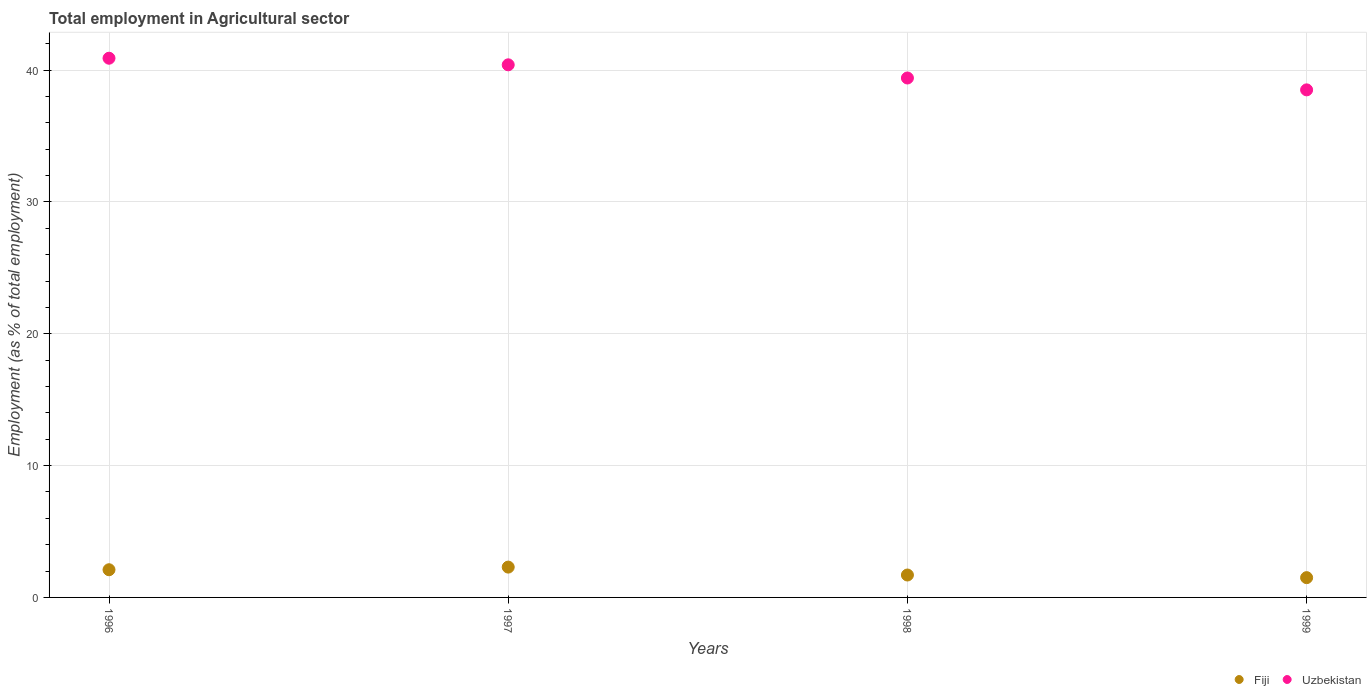What is the employment in agricultural sector in Fiji in 1996?
Give a very brief answer. 2.1. Across all years, what is the maximum employment in agricultural sector in Fiji?
Provide a succinct answer. 2.3. Across all years, what is the minimum employment in agricultural sector in Fiji?
Keep it short and to the point. 1.5. In which year was the employment in agricultural sector in Uzbekistan minimum?
Provide a succinct answer. 1999. What is the total employment in agricultural sector in Uzbekistan in the graph?
Ensure brevity in your answer.  159.2. What is the difference between the employment in agricultural sector in Fiji in 1997 and that in 1999?
Your response must be concise. 0.8. What is the difference between the employment in agricultural sector in Fiji in 1997 and the employment in agricultural sector in Uzbekistan in 1999?
Provide a short and direct response. -36.2. What is the average employment in agricultural sector in Uzbekistan per year?
Your answer should be very brief. 39.8. In the year 1999, what is the difference between the employment in agricultural sector in Fiji and employment in agricultural sector in Uzbekistan?
Give a very brief answer. -37. In how many years, is the employment in agricultural sector in Uzbekistan greater than 16 %?
Keep it short and to the point. 4. What is the ratio of the employment in agricultural sector in Fiji in 1998 to that in 1999?
Your response must be concise. 1.13. Is the employment in agricultural sector in Uzbekistan in 1998 less than that in 1999?
Your answer should be very brief. No. What is the difference between the highest and the second highest employment in agricultural sector in Uzbekistan?
Make the answer very short. 0.5. What is the difference between the highest and the lowest employment in agricultural sector in Uzbekistan?
Make the answer very short. 2.4. In how many years, is the employment in agricultural sector in Uzbekistan greater than the average employment in agricultural sector in Uzbekistan taken over all years?
Your answer should be very brief. 2. Is the employment in agricultural sector in Uzbekistan strictly less than the employment in agricultural sector in Fiji over the years?
Provide a short and direct response. No. How many dotlines are there?
Your answer should be very brief. 2. How many years are there in the graph?
Your answer should be very brief. 4. Are the values on the major ticks of Y-axis written in scientific E-notation?
Your response must be concise. No. Where does the legend appear in the graph?
Provide a succinct answer. Bottom right. How are the legend labels stacked?
Your answer should be very brief. Horizontal. What is the title of the graph?
Provide a short and direct response. Total employment in Agricultural sector. What is the label or title of the X-axis?
Your answer should be very brief. Years. What is the label or title of the Y-axis?
Keep it short and to the point. Employment (as % of total employment). What is the Employment (as % of total employment) in Fiji in 1996?
Offer a terse response. 2.1. What is the Employment (as % of total employment) in Uzbekistan in 1996?
Your answer should be compact. 40.9. What is the Employment (as % of total employment) of Fiji in 1997?
Give a very brief answer. 2.3. What is the Employment (as % of total employment) of Uzbekistan in 1997?
Ensure brevity in your answer.  40.4. What is the Employment (as % of total employment) of Fiji in 1998?
Keep it short and to the point. 1.7. What is the Employment (as % of total employment) of Uzbekistan in 1998?
Offer a terse response. 39.4. What is the Employment (as % of total employment) of Uzbekistan in 1999?
Provide a succinct answer. 38.5. Across all years, what is the maximum Employment (as % of total employment) of Fiji?
Your response must be concise. 2.3. Across all years, what is the maximum Employment (as % of total employment) in Uzbekistan?
Ensure brevity in your answer.  40.9. Across all years, what is the minimum Employment (as % of total employment) of Fiji?
Keep it short and to the point. 1.5. Across all years, what is the minimum Employment (as % of total employment) in Uzbekistan?
Provide a short and direct response. 38.5. What is the total Employment (as % of total employment) of Fiji in the graph?
Offer a terse response. 7.6. What is the total Employment (as % of total employment) of Uzbekistan in the graph?
Provide a succinct answer. 159.2. What is the difference between the Employment (as % of total employment) of Uzbekistan in 1996 and that in 1998?
Provide a succinct answer. 1.5. What is the difference between the Employment (as % of total employment) in Fiji in 1996 and that in 1999?
Your response must be concise. 0.6. What is the difference between the Employment (as % of total employment) in Uzbekistan in 1997 and that in 1998?
Your answer should be compact. 1. What is the difference between the Employment (as % of total employment) in Uzbekistan in 1997 and that in 1999?
Provide a succinct answer. 1.9. What is the difference between the Employment (as % of total employment) of Fiji in 1998 and that in 1999?
Provide a short and direct response. 0.2. What is the difference between the Employment (as % of total employment) in Uzbekistan in 1998 and that in 1999?
Your answer should be very brief. 0.9. What is the difference between the Employment (as % of total employment) of Fiji in 1996 and the Employment (as % of total employment) of Uzbekistan in 1997?
Offer a very short reply. -38.3. What is the difference between the Employment (as % of total employment) in Fiji in 1996 and the Employment (as % of total employment) in Uzbekistan in 1998?
Give a very brief answer. -37.3. What is the difference between the Employment (as % of total employment) of Fiji in 1996 and the Employment (as % of total employment) of Uzbekistan in 1999?
Make the answer very short. -36.4. What is the difference between the Employment (as % of total employment) of Fiji in 1997 and the Employment (as % of total employment) of Uzbekistan in 1998?
Offer a very short reply. -37.1. What is the difference between the Employment (as % of total employment) of Fiji in 1997 and the Employment (as % of total employment) of Uzbekistan in 1999?
Your response must be concise. -36.2. What is the difference between the Employment (as % of total employment) in Fiji in 1998 and the Employment (as % of total employment) in Uzbekistan in 1999?
Your answer should be very brief. -36.8. What is the average Employment (as % of total employment) in Uzbekistan per year?
Your answer should be very brief. 39.8. In the year 1996, what is the difference between the Employment (as % of total employment) of Fiji and Employment (as % of total employment) of Uzbekistan?
Your response must be concise. -38.8. In the year 1997, what is the difference between the Employment (as % of total employment) of Fiji and Employment (as % of total employment) of Uzbekistan?
Give a very brief answer. -38.1. In the year 1998, what is the difference between the Employment (as % of total employment) in Fiji and Employment (as % of total employment) in Uzbekistan?
Your answer should be very brief. -37.7. In the year 1999, what is the difference between the Employment (as % of total employment) in Fiji and Employment (as % of total employment) in Uzbekistan?
Give a very brief answer. -37. What is the ratio of the Employment (as % of total employment) in Fiji in 1996 to that in 1997?
Your response must be concise. 0.91. What is the ratio of the Employment (as % of total employment) of Uzbekistan in 1996 to that in 1997?
Keep it short and to the point. 1.01. What is the ratio of the Employment (as % of total employment) in Fiji in 1996 to that in 1998?
Provide a short and direct response. 1.24. What is the ratio of the Employment (as % of total employment) in Uzbekistan in 1996 to that in 1998?
Make the answer very short. 1.04. What is the ratio of the Employment (as % of total employment) of Fiji in 1996 to that in 1999?
Give a very brief answer. 1.4. What is the ratio of the Employment (as % of total employment) in Uzbekistan in 1996 to that in 1999?
Provide a succinct answer. 1.06. What is the ratio of the Employment (as % of total employment) in Fiji in 1997 to that in 1998?
Provide a succinct answer. 1.35. What is the ratio of the Employment (as % of total employment) in Uzbekistan in 1997 to that in 1998?
Your answer should be very brief. 1.03. What is the ratio of the Employment (as % of total employment) in Fiji in 1997 to that in 1999?
Provide a short and direct response. 1.53. What is the ratio of the Employment (as % of total employment) in Uzbekistan in 1997 to that in 1999?
Keep it short and to the point. 1.05. What is the ratio of the Employment (as % of total employment) of Fiji in 1998 to that in 1999?
Your response must be concise. 1.13. What is the ratio of the Employment (as % of total employment) in Uzbekistan in 1998 to that in 1999?
Your answer should be very brief. 1.02. What is the difference between the highest and the second highest Employment (as % of total employment) of Uzbekistan?
Your response must be concise. 0.5. What is the difference between the highest and the lowest Employment (as % of total employment) in Fiji?
Ensure brevity in your answer.  0.8. What is the difference between the highest and the lowest Employment (as % of total employment) in Uzbekistan?
Offer a terse response. 2.4. 